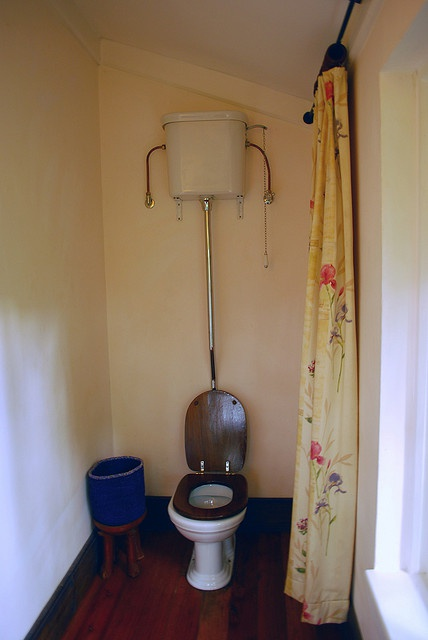Describe the objects in this image and their specific colors. I can see toilet in gray, black, darkgray, and maroon tones and chair in black, maroon, navy, and gray tones in this image. 